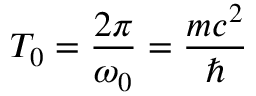Convert formula to latex. <formula><loc_0><loc_0><loc_500><loc_500>T _ { 0 } = \frac { 2 \pi } { \omega _ { 0 } } = \frac { m c ^ { 2 } } { }</formula> 